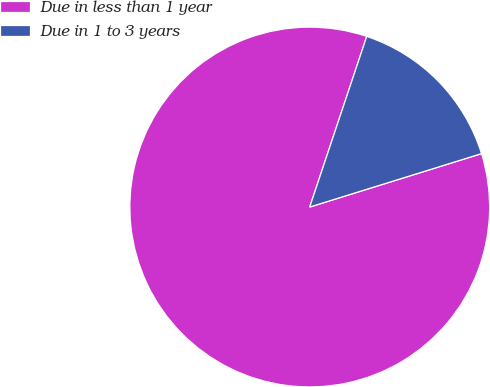Convert chart. <chart><loc_0><loc_0><loc_500><loc_500><pie_chart><fcel>Due in less than 1 year<fcel>Due in 1 to 3 years<nl><fcel>84.93%<fcel>15.07%<nl></chart> 